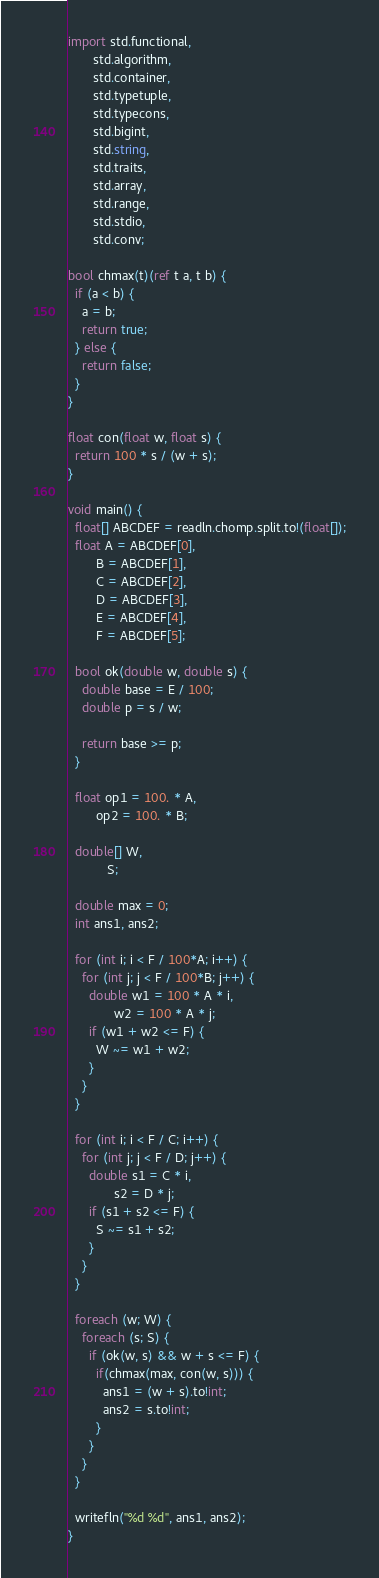Convert code to text. <code><loc_0><loc_0><loc_500><loc_500><_D_>import std.functional,
       std.algorithm,
       std.container,
       std.typetuple,
       std.typecons,
       std.bigint,
       std.string,
       std.traits,
       std.array,
       std.range,
       std.stdio,
       std.conv;

bool chmax(t)(ref t a, t b) {
  if (a < b) {
    a = b;
    return true;
  } else {
    return false;
  }
}

float con(float w, float s) {
  return 100 * s / (w + s);
}

void main() {
  float[] ABCDEF = readln.chomp.split.to!(float[]);
  float A = ABCDEF[0],
        B = ABCDEF[1],
        C = ABCDEF[2],
        D = ABCDEF[3],
        E = ABCDEF[4],
        F = ABCDEF[5];

  bool ok(double w, double s) {
    double base = E / 100;
    double p = s / w;

    return base >= p;
  }

  float op1 = 100. * A,
        op2 = 100. * B;

  double[] W,
           S;

  double max = 0;
  int ans1, ans2;

  for (int i; i < F / 100*A; i++) {
    for (int j; j < F / 100*B; j++) {
      double w1 = 100 * A * i,
             w2 = 100 * A * j;
      if (w1 + w2 <= F) {
        W ~= w1 + w2;
      }
    }
  }

  for (int i; i < F / C; i++) {
    for (int j; j < F / D; j++) {
      double s1 = C * i,
             s2 = D * j;
      if (s1 + s2 <= F) {
        S ~= s1 + s2;
      }
    }
  }

  foreach (w; W) {
    foreach (s; S) {
      if (ok(w, s) && w + s <= F) {
        if(chmax(max, con(w, s))) {
          ans1 = (w + s).to!int;
          ans2 = s.to!int;
        }
      }
    }
  }

  writefln("%d %d", ans1, ans2);
}
</code> 